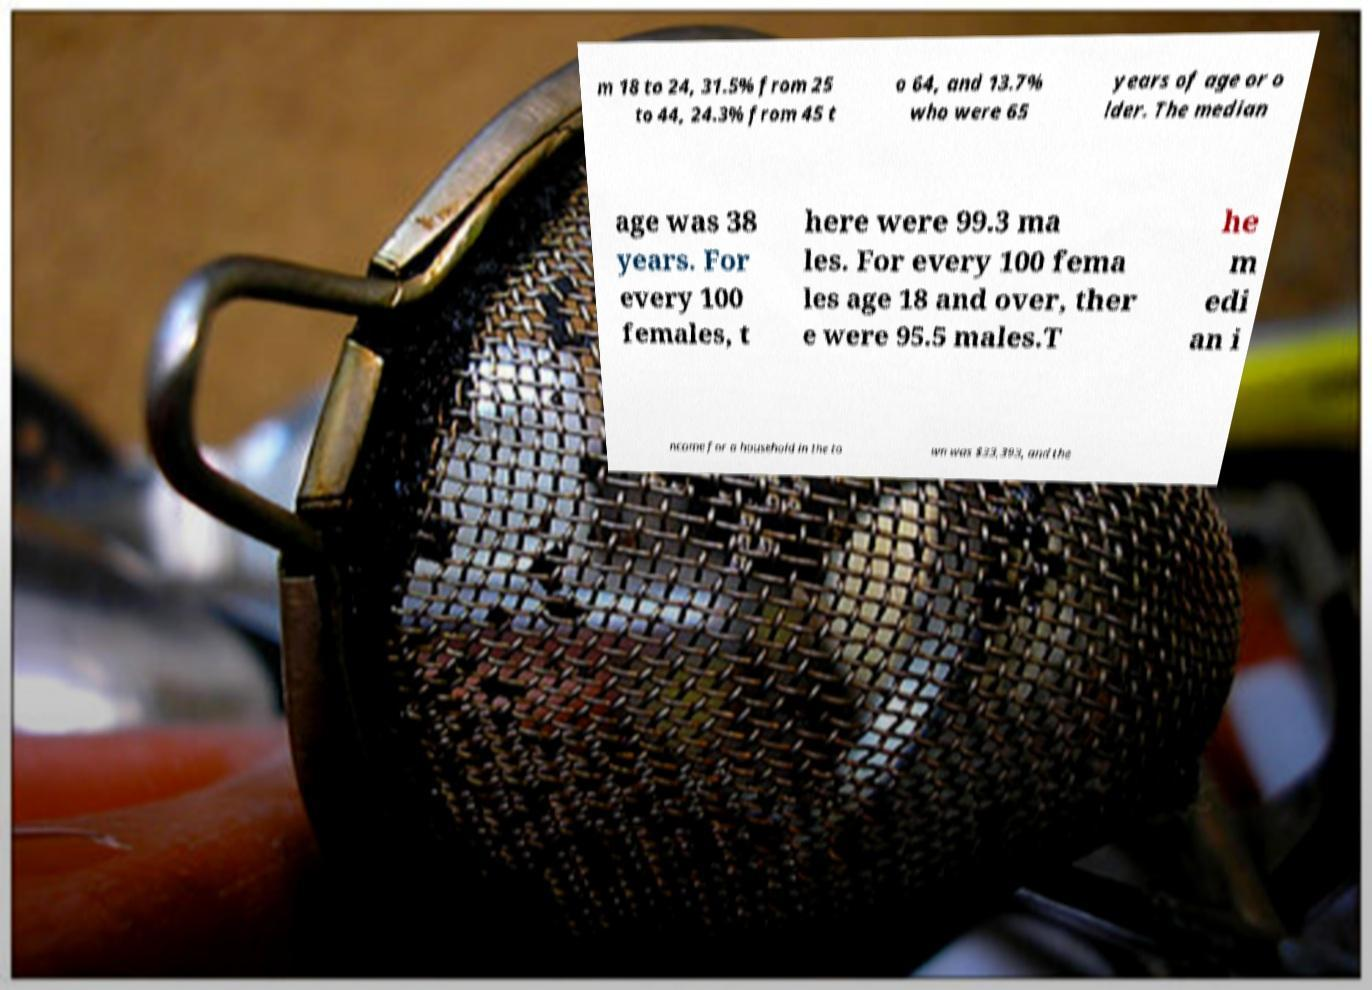For documentation purposes, I need the text within this image transcribed. Could you provide that? m 18 to 24, 31.5% from 25 to 44, 24.3% from 45 t o 64, and 13.7% who were 65 years of age or o lder. The median age was 38 years. For every 100 females, t here were 99.3 ma les. For every 100 fema les age 18 and over, ther e were 95.5 males.T he m edi an i ncome for a household in the to wn was $33,393, and the 